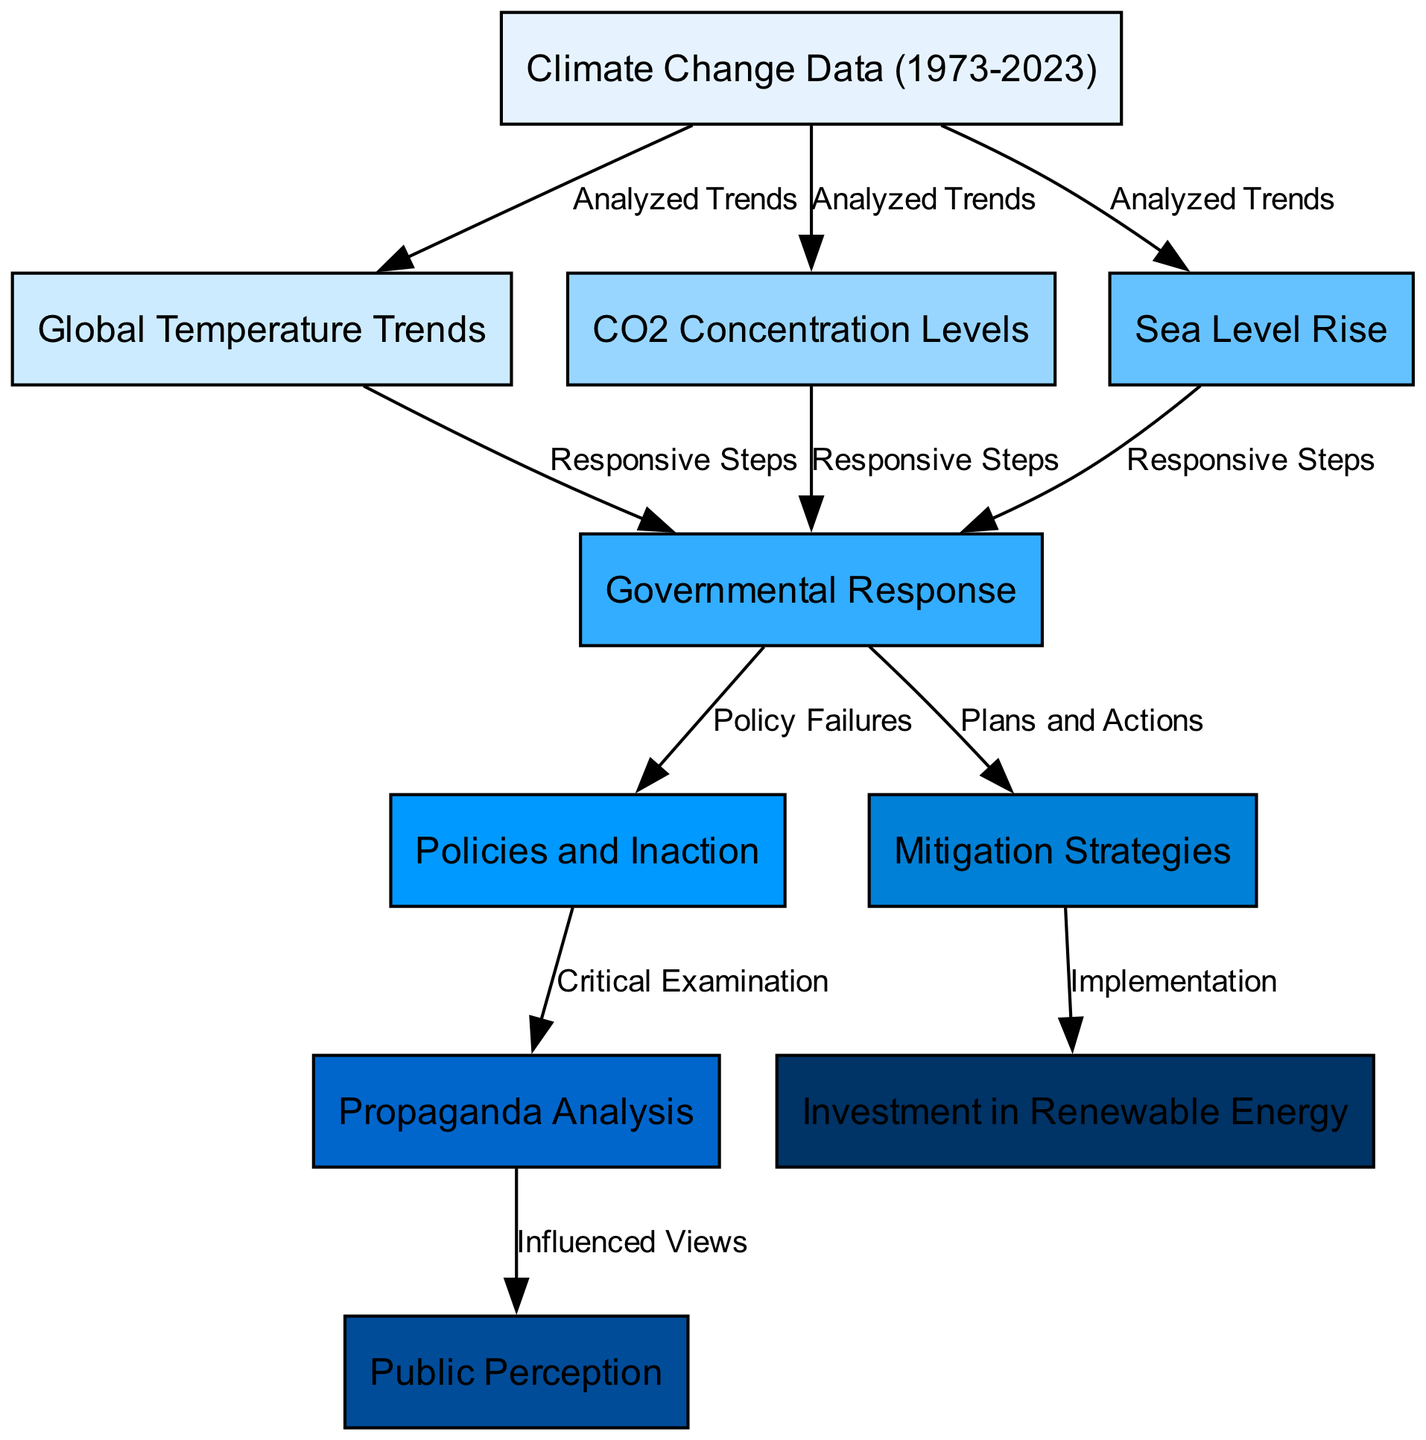What are the three main climate change data types analyzed? The diagram shows three main data types analyzed: Global Temperature Trends, CO2 Concentration Levels, and Sea Level Rise, as represented by the connections from the Climate Change Data node.
Answer: Global Temperature Trends, CO2 Concentration Levels, Sea Level Rise How many nodes are present in the diagram? By counting all the distinct labeled rectangles in the diagram, we find that there are ten nodes representing various concepts related to climate change.
Answer: 10 What connection links Governmental Response to Sea Level Rise? The edge labeled "Responsive Steps" shows the direct link between Governmental Response and Sea Level Rise, indicating that government actions are influenced by rising sea levels.
Answer: Responsive Steps What does the node "Policy Failures" indicate? The connection from Governmental Response to Policy Failures suggests that the government's response to climate change is often inadequate or ineffective, leading to failures in policy.
Answer: Policy Failures Which node indicates strategies for addressing climate change? The node labeled "Mitigation Strategies" indicates specific strategies that the government or other entities aim to implement to address the effects of climate change.
Answer: Mitigation Strategies How does Public Perception relate to Propaganda Analysis? The edge labeled "Influenced Views" signifies that public perception is shaped by the analysis of propaganda, indicating that governmental narratives can affect how people view climate change.
Answer: Influenced Views What strategy is linked to Investment in Renewable Energy? The connection labeled "Implementation" shows that Investment in Renewable Energy is part of the broader Mitigation Strategies, meaning that renewable energy investments are strategies being implemented to combat climate change.
Answer: Implementation What is depicted as a critical examination within the diagram? The edge from Policy Failures to Propaganda Analysis suggests that examining the failures in policy is a critical step towards understanding the role of propaganda in governmental responses.
Answer: Critical Examination Which aspect of climate data influences government response directly? The three analyzed trends—Global Temperature Trends, CO2 Concentration Levels, and Sea Level Rise—all directly influence the Governmental Response, indicating a direct relationship where data impacts policy decisions.
Answer: Responsive Steps 